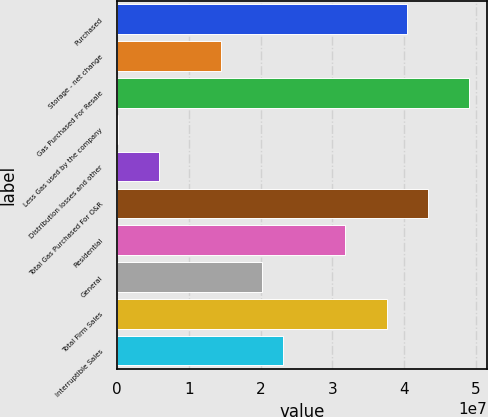Convert chart. <chart><loc_0><loc_0><loc_500><loc_500><bar_chart><fcel>Purchased<fcel>Storage - net change<fcel>Gas Purchased For Resale<fcel>Less Gas used by the company<fcel>Distribution losses and other<fcel>Total Gas Purchased For O&R<fcel>Residential<fcel>General<fcel>Total Firm Sales<fcel>Interruptible Sales<nl><fcel>4.04597e+07<fcel>1.44741e+07<fcel>4.91216e+07<fcel>37630<fcel>5.81221e+06<fcel>4.3347e+07<fcel>3.17978e+07<fcel>2.02487e+07<fcel>3.75724e+07<fcel>2.31359e+07<nl></chart> 